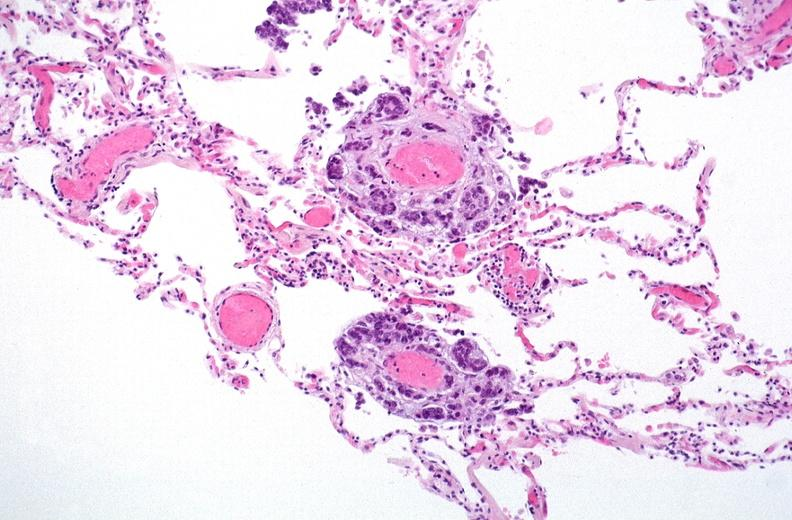what does this image show?
Answer the question using a single word or phrase. Breast cancer metastasis to lung 